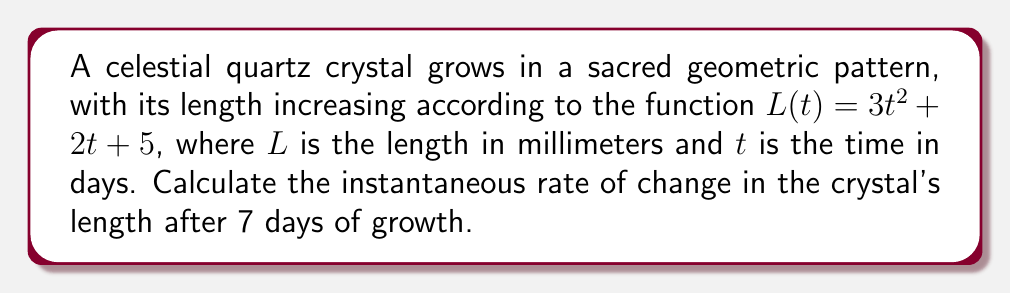Show me your answer to this math problem. To find the instantaneous rate of change, we need to calculate the derivative of the length function $L(t)$ and then evaluate it at $t = 7$.

Step 1: Find the derivative of $L(t)$
$L(t) = 3t^2 + 2t + 5$
$L'(t) = \frac{d}{dt}(3t^2 + 2t + 5)$
$L'(t) = 6t + 2$

Step 2: Evaluate $L'(t)$ at $t = 7$
$L'(7) = 6(7) + 2$
$L'(7) = 42 + 2 = 44$

Therefore, the instantaneous rate of change in the crystal's length after 7 days is 44 mm/day.
Answer: 44 mm/day 